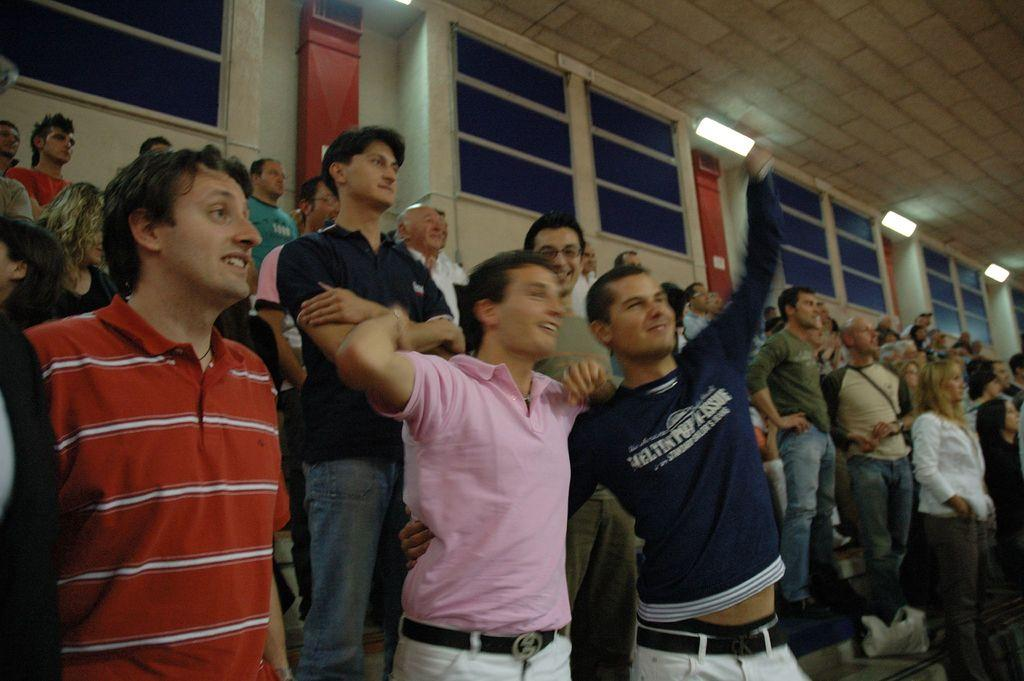What types of people are in the image? There are men and women standing in the image. What can be seen at the top of the image? There is a blue color glass window at the top of the image. What is present in the image that provides illumination? Lights are present in the image. What type of ink is being used in the discussion in the image? There is no discussion or ink present in the image; it features men and women standing near a blue color glass window with lights. 